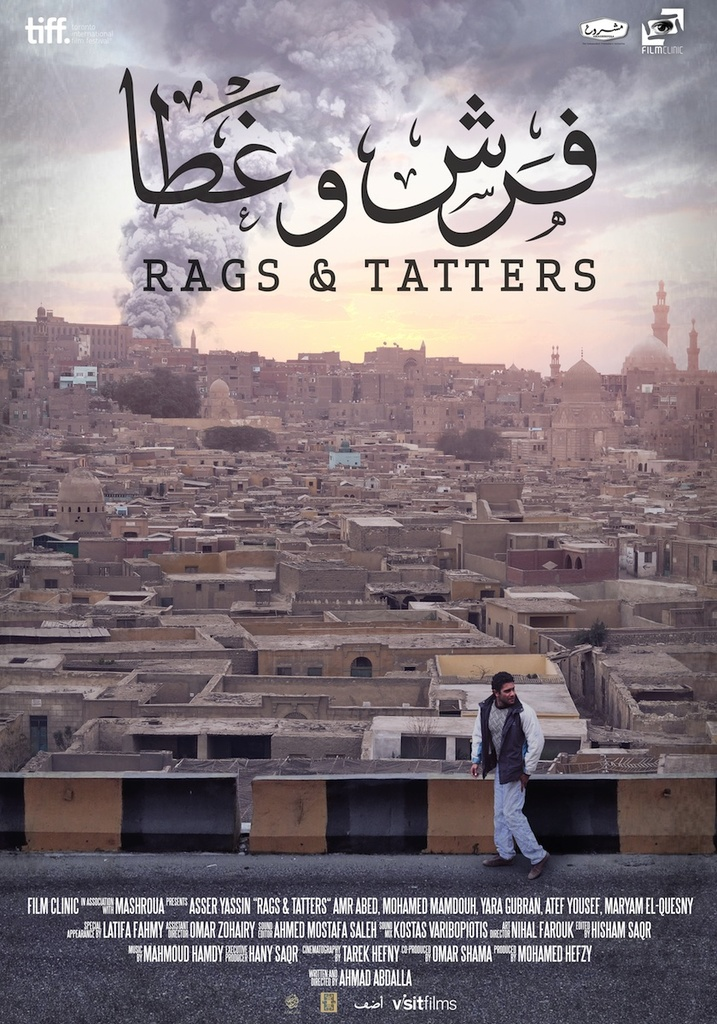What does the image of the man on the rooftop signify in the context of the film's title and overall aesthetics? The man’s solitary figure standing on the rooftop, overlooking a vast city, visually represents themes of isolation and perspective. This imagery, when combined with the film’s title 'Rags & Tatters,' may suggest a narrative exploring social disparity or individual insignificance against the sprawling urban environment. The aesthetic choice of subdued colors and historical buildings possibly echoes the film’s focus on the gritty, real-life issues faced by individuals in urban settings, possibly pointing at the socio-economic contrasts within the city. 